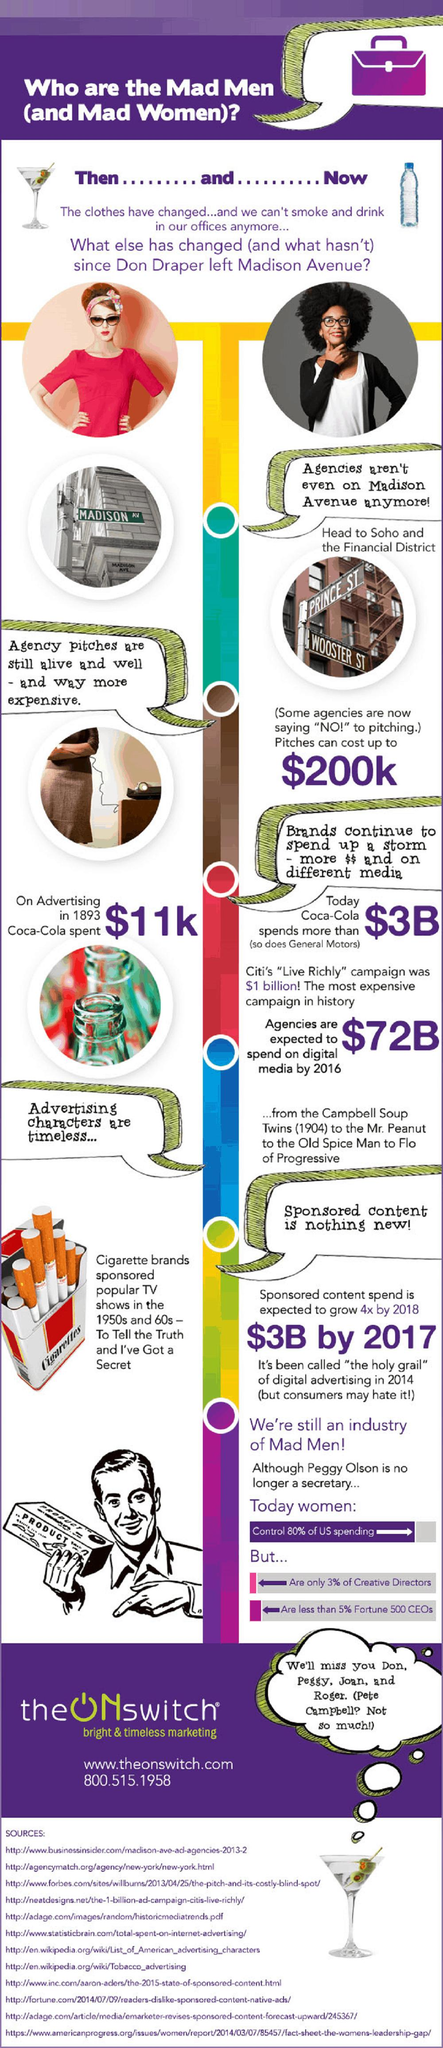List a handful of essential elements in this visual. Coca-Cola spent a significant amount on advertising, with a figure ranging from $11k to $3 billion to $72 billion. The company invested the highest amount, $3 billion, on advertising. Prince and Wooster streets are located in Soho. 